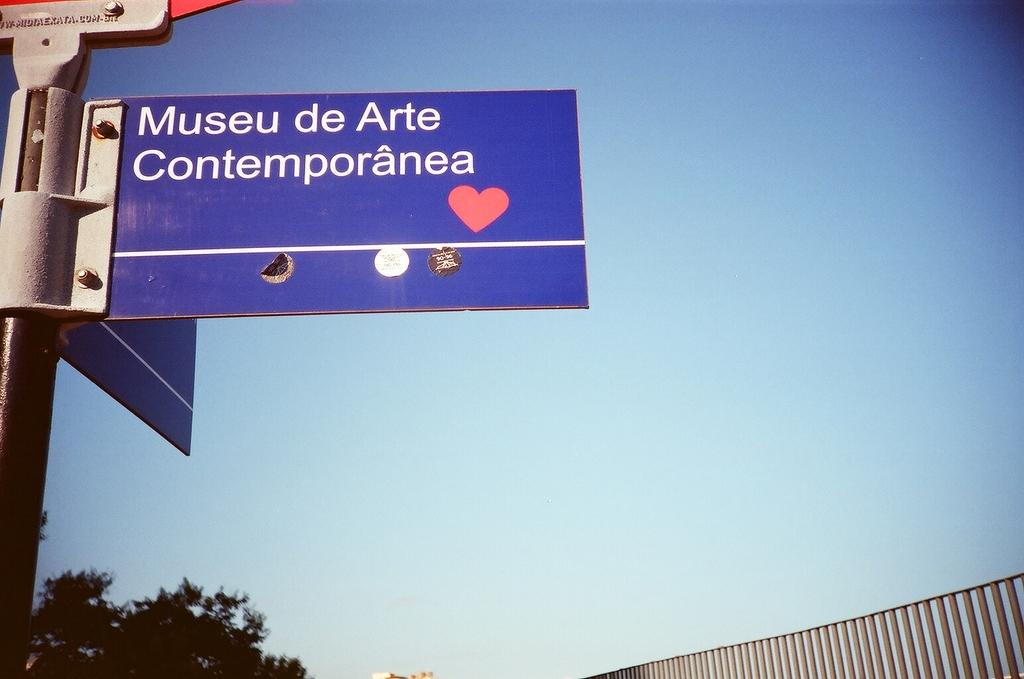Provide a one-sentence caption for the provided image. A blue sign that says Museu de Arte Contemporanea in front of a blue sky. 